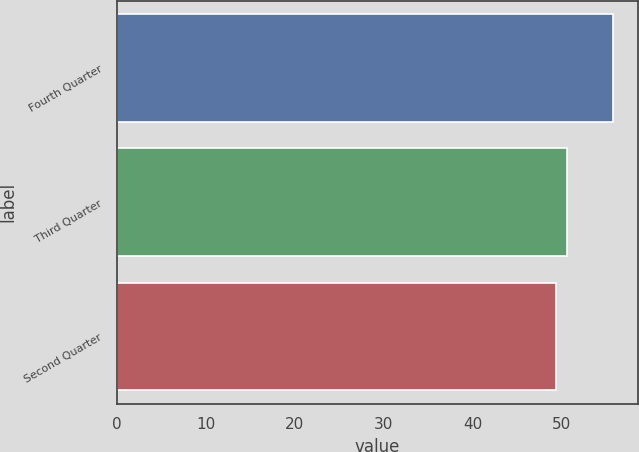Convert chart. <chart><loc_0><loc_0><loc_500><loc_500><bar_chart><fcel>Fourth Quarter<fcel>Third Quarter<fcel>Second Quarter<nl><fcel>55.86<fcel>50.61<fcel>49.45<nl></chart> 